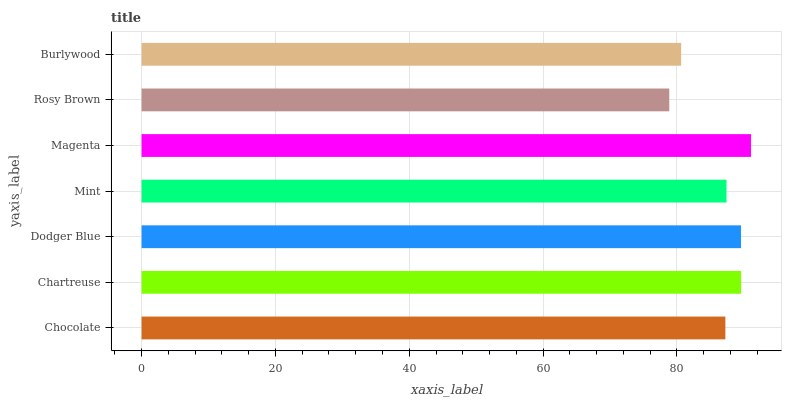Is Rosy Brown the minimum?
Answer yes or no. Yes. Is Magenta the maximum?
Answer yes or no. Yes. Is Chartreuse the minimum?
Answer yes or no. No. Is Chartreuse the maximum?
Answer yes or no. No. Is Chartreuse greater than Chocolate?
Answer yes or no. Yes. Is Chocolate less than Chartreuse?
Answer yes or no. Yes. Is Chocolate greater than Chartreuse?
Answer yes or no. No. Is Chartreuse less than Chocolate?
Answer yes or no. No. Is Mint the high median?
Answer yes or no. Yes. Is Mint the low median?
Answer yes or no. Yes. Is Magenta the high median?
Answer yes or no. No. Is Dodger Blue the low median?
Answer yes or no. No. 